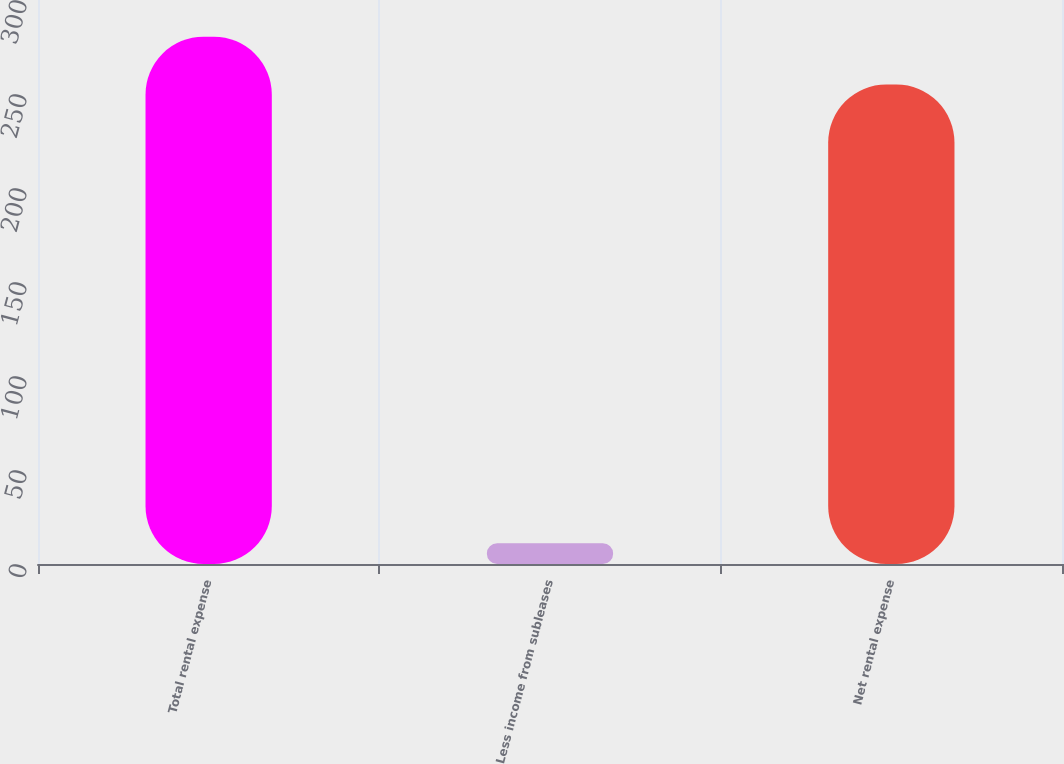Convert chart to OTSL. <chart><loc_0><loc_0><loc_500><loc_500><bar_chart><fcel>Total rental expense<fcel>Less income from subleases<fcel>Net rental expense<nl><fcel>280.5<fcel>11<fcel>255<nl></chart> 